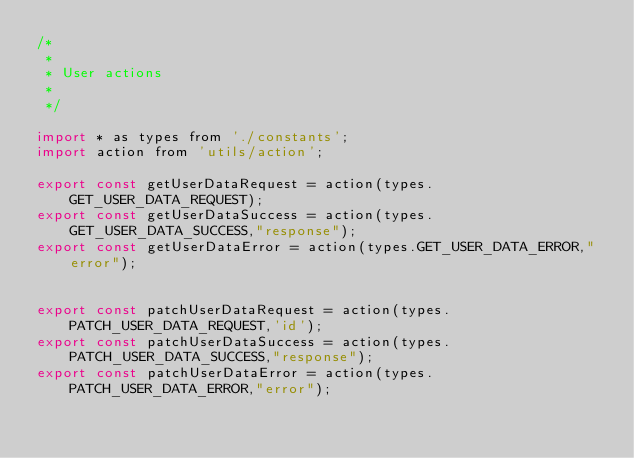Convert code to text. <code><loc_0><loc_0><loc_500><loc_500><_JavaScript_>/*
 *
 * User actions
 *
 */

import * as types from './constants';
import action from 'utils/action';

export const getUserDataRequest = action(types.GET_USER_DATA_REQUEST);
export const getUserDataSuccess = action(types.GET_USER_DATA_SUCCESS,"response");
export const getUserDataError = action(types.GET_USER_DATA_ERROR,"error");


export const patchUserDataRequest = action(types.PATCH_USER_DATA_REQUEST,'id');
export const patchUserDataSuccess = action(types.PATCH_USER_DATA_SUCCESS,"response");
export const patchUserDataError = action(types.PATCH_USER_DATA_ERROR,"error");</code> 